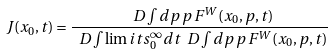Convert formula to latex. <formula><loc_0><loc_0><loc_500><loc_500>J ( x _ { 0 } , t ) = \frac { \ D \int d p \, p \, F ^ { W } ( x _ { 0 } , p , t ) } { \ D \int \lim i t s _ { 0 } ^ { \infty } d t \ D \int d p \, p \, F ^ { W } ( x _ { 0 } , p , t ) }</formula> 